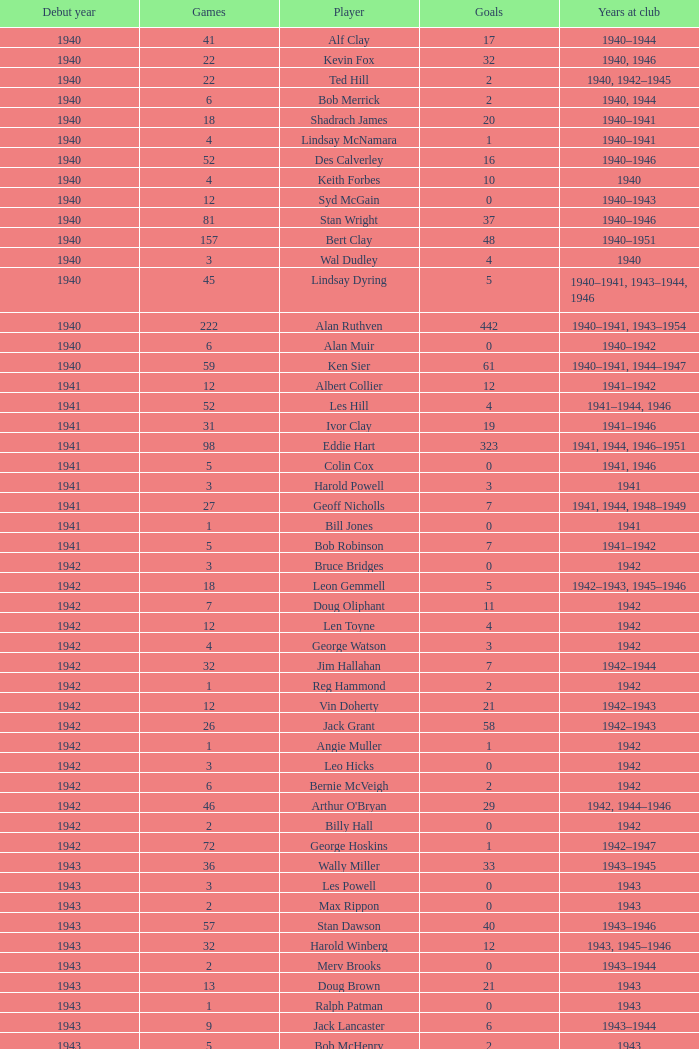Which player debuted before 1943, played for the club in 1942, played less than 12 games, and scored less than 11 goals? Bruce Bridges, George Watson, Reg Hammond, Angie Muller, Leo Hicks, Bernie McVeigh, Billy Hall. 